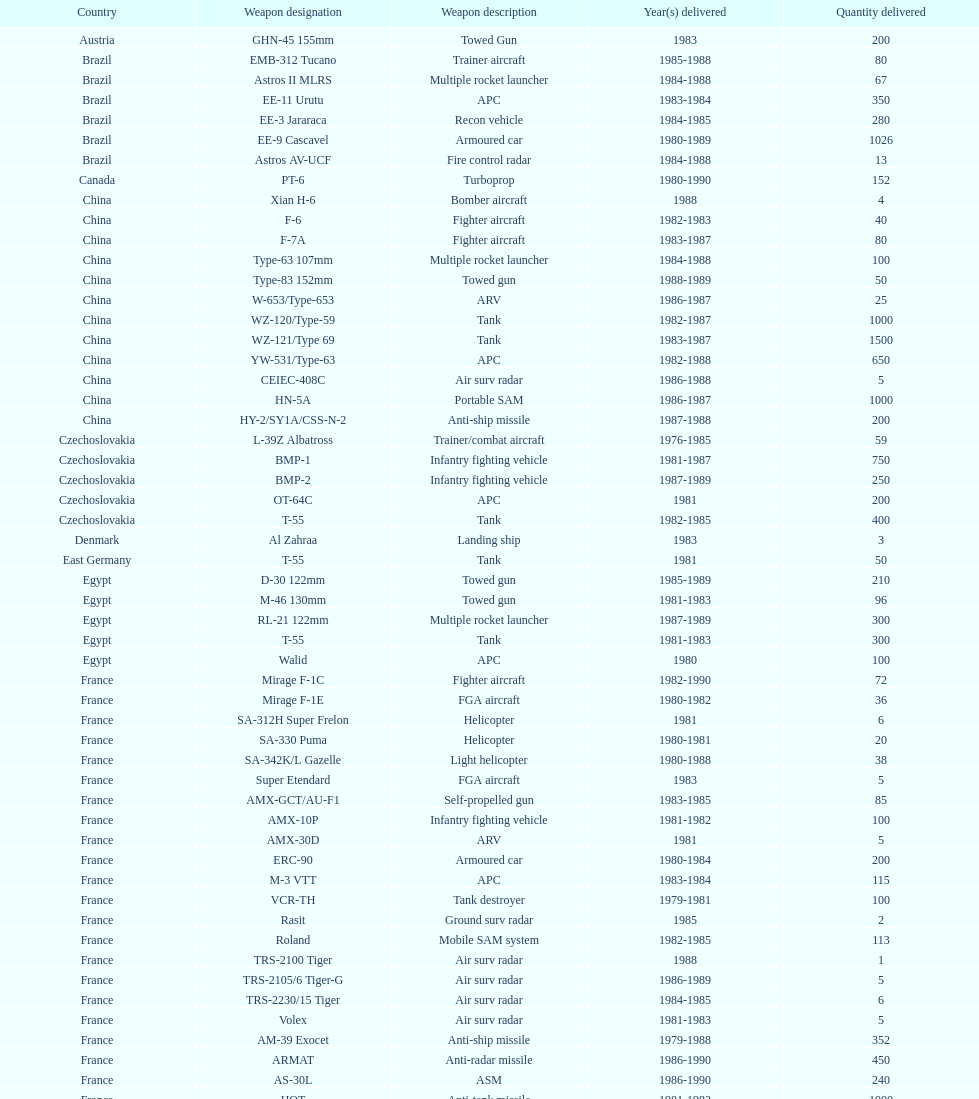Based on this list, how many nations supplied arms to iraq? 21. Can you give me this table as a dict? {'header': ['Country', 'Weapon designation', 'Weapon description', 'Year(s) delivered', 'Quantity delivered'], 'rows': [['Austria', 'GHN-45 155mm', 'Towed Gun', '1983', '200'], ['Brazil', 'EMB-312 Tucano', 'Trainer aircraft', '1985-1988', '80'], ['Brazil', 'Astros II MLRS', 'Multiple rocket launcher', '1984-1988', '67'], ['Brazil', 'EE-11 Urutu', 'APC', '1983-1984', '350'], ['Brazil', 'EE-3 Jararaca', 'Recon vehicle', '1984-1985', '280'], ['Brazil', 'EE-9 Cascavel', 'Armoured car', '1980-1989', '1026'], ['Brazil', 'Astros AV-UCF', 'Fire control radar', '1984-1988', '13'], ['Canada', 'PT-6', 'Turboprop', '1980-1990', '152'], ['China', 'Xian H-6', 'Bomber aircraft', '1988', '4'], ['China', 'F-6', 'Fighter aircraft', '1982-1983', '40'], ['China', 'F-7A', 'Fighter aircraft', '1983-1987', '80'], ['China', 'Type-63 107mm', 'Multiple rocket launcher', '1984-1988', '100'], ['China', 'Type-83 152mm', 'Towed gun', '1988-1989', '50'], ['China', 'W-653/Type-653', 'ARV', '1986-1987', '25'], ['China', 'WZ-120/Type-59', 'Tank', '1982-1987', '1000'], ['China', 'WZ-121/Type 69', 'Tank', '1983-1987', '1500'], ['China', 'YW-531/Type-63', 'APC', '1982-1988', '650'], ['China', 'CEIEC-408C', 'Air surv radar', '1986-1988', '5'], ['China', 'HN-5A', 'Portable SAM', '1986-1987', '1000'], ['China', 'HY-2/SY1A/CSS-N-2', 'Anti-ship missile', '1987-1988', '200'], ['Czechoslovakia', 'L-39Z Albatross', 'Trainer/combat aircraft', '1976-1985', '59'], ['Czechoslovakia', 'BMP-1', 'Infantry fighting vehicle', '1981-1987', '750'], ['Czechoslovakia', 'BMP-2', 'Infantry fighting vehicle', '1987-1989', '250'], ['Czechoslovakia', 'OT-64C', 'APC', '1981', '200'], ['Czechoslovakia', 'T-55', 'Tank', '1982-1985', '400'], ['Denmark', 'Al Zahraa', 'Landing ship', '1983', '3'], ['East Germany', 'T-55', 'Tank', '1981', '50'], ['Egypt', 'D-30 122mm', 'Towed gun', '1985-1989', '210'], ['Egypt', 'M-46 130mm', 'Towed gun', '1981-1983', '96'], ['Egypt', 'RL-21 122mm', 'Multiple rocket launcher', '1987-1989', '300'], ['Egypt', 'T-55', 'Tank', '1981-1983', '300'], ['Egypt', 'Walid', 'APC', '1980', '100'], ['France', 'Mirage F-1C', 'Fighter aircraft', '1982-1990', '72'], ['France', 'Mirage F-1E', 'FGA aircraft', '1980-1982', '36'], ['France', 'SA-312H Super Frelon', 'Helicopter', '1981', '6'], ['France', 'SA-330 Puma', 'Helicopter', '1980-1981', '20'], ['France', 'SA-342K/L Gazelle', 'Light helicopter', '1980-1988', '38'], ['France', 'Super Etendard', 'FGA aircraft', '1983', '5'], ['France', 'AMX-GCT/AU-F1', 'Self-propelled gun', '1983-1985', '85'], ['France', 'AMX-10P', 'Infantry fighting vehicle', '1981-1982', '100'], ['France', 'AMX-30D', 'ARV', '1981', '5'], ['France', 'ERC-90', 'Armoured car', '1980-1984', '200'], ['France', 'M-3 VTT', 'APC', '1983-1984', '115'], ['France', 'VCR-TH', 'Tank destroyer', '1979-1981', '100'], ['France', 'Rasit', 'Ground surv radar', '1985', '2'], ['France', 'Roland', 'Mobile SAM system', '1982-1985', '113'], ['France', 'TRS-2100 Tiger', 'Air surv radar', '1988', '1'], ['France', 'TRS-2105/6 Tiger-G', 'Air surv radar', '1986-1989', '5'], ['France', 'TRS-2230/15 Tiger', 'Air surv radar', '1984-1985', '6'], ['France', 'Volex', 'Air surv radar', '1981-1983', '5'], ['France', 'AM-39 Exocet', 'Anti-ship missile', '1979-1988', '352'], ['France', 'ARMAT', 'Anti-radar missile', '1986-1990', '450'], ['France', 'AS-30L', 'ASM', '1986-1990', '240'], ['France', 'HOT', 'Anti-tank missile', '1981-1982', '1000'], ['France', 'R-550 Magic-1', 'SRAAM', '1981-1985', '534'], ['France', 'Roland-2', 'SAM', '1981-1990', '2260'], ['France', 'Super 530F', 'BVRAAM', '1981-1985', '300'], ['West Germany', 'BK-117', 'Helicopter', '1984-1989', '22'], ['West Germany', 'Bo-105C', 'Light Helicopter', '1979-1982', '20'], ['West Germany', 'Bo-105L', 'Light Helicopter', '1988', '6'], ['Hungary', 'PSZH-D-994', 'APC', '1981', '300'], ['Italy', 'A-109 Hirundo', 'Light Helicopter', '1982', '2'], ['Italy', 'S-61', 'Helicopter', '1982', '6'], ['Italy', 'Stromboli class', 'Support ship', '1981', '1'], ['Jordan', 'S-76 Spirit', 'Helicopter', '1985', '2'], ['Poland', 'Mi-2/Hoplite', 'Helicopter', '1984-1985', '15'], ['Poland', 'MT-LB', 'APC', '1983-1990', '750'], ['Poland', 'T-55', 'Tank', '1981-1982', '400'], ['Poland', 'T-72M1', 'Tank', '1982-1990', '500'], ['Romania', 'T-55', 'Tank', '1982-1984', '150'], ['Yugoslavia', 'M-87 Orkan 262mm', 'Multiple rocket launcher', '1988', '2'], ['South Africa', 'G-5 155mm', 'Towed gun', '1985-1988', '200'], ['Switzerland', 'PC-7 Turbo trainer', 'Trainer aircraft', '1980-1983', '52'], ['Switzerland', 'PC-9', 'Trainer aircraft', '1987-1990', '20'], ['Switzerland', 'Roland', 'APC/IFV', '1981', '100'], ['United Kingdom', 'Chieftain/ARV', 'ARV', '1982', '29'], ['United Kingdom', 'Cymbeline', 'Arty locating radar', '1986-1988', '10'], ['United States', 'MD-500MD Defender', 'Light Helicopter', '1983', '30'], ['United States', 'Hughes-300/TH-55', 'Light Helicopter', '1983', '30'], ['United States', 'MD-530F', 'Light Helicopter', '1986', '26'], ['United States', 'Bell 214ST', 'Helicopter', '1988', '31'], ['Soviet Union', 'Il-76M/Candid-B', 'Strategic airlifter', '1978-1984', '33'], ['Soviet Union', 'Mi-24D/Mi-25/Hind-D', 'Attack helicopter', '1978-1984', '12'], ['Soviet Union', 'Mi-8/Mi-17/Hip-H', 'Transport helicopter', '1986-1987', '37'], ['Soviet Union', 'Mi-8TV/Hip-F', 'Transport helicopter', '1984', '30'], ['Soviet Union', 'Mig-21bis/Fishbed-N', 'Fighter aircraft', '1983-1984', '61'], ['Soviet Union', 'Mig-23BN/Flogger-H', 'FGA aircraft', '1984-1985', '50'], ['Soviet Union', 'Mig-25P/Foxbat-A', 'Interceptor aircraft', '1980-1985', '55'], ['Soviet Union', 'Mig-25RB/Foxbat-B', 'Recon aircraft', '1982', '8'], ['Soviet Union', 'Mig-29/Fulcrum-A', 'Fighter aircraft', '1986-1989', '41'], ['Soviet Union', 'Su-22/Fitter-H/J/K', 'FGA aircraft', '1986-1987', '61'], ['Soviet Union', 'Su-25/Frogfoot-A', 'Ground attack aircraft', '1986-1987', '84'], ['Soviet Union', '2A36 152mm', 'Towed gun', '1986-1988', '180'], ['Soviet Union', '2S1 122mm', 'Self-Propelled Howitzer', '1980-1989', '150'], ['Soviet Union', '2S3 152mm', 'Self-propelled gun', '1980-1989', '150'], ['Soviet Union', '2S4 240mm', 'Self-propelled mortar', '1983', '10'], ['Soviet Union', '9P117/SS-1 Scud TEL', 'SSM launcher', '1983-1984', '10'], ['Soviet Union', 'BM-21 Grad 122mm', 'Multiple rocket launcher', '1983-1988', '560'], ['Soviet Union', 'D-30 122mm', 'Towed gun', '1982-1988', '576'], ['Soviet Union', 'M-240 240mm', 'Mortar', '1981', '25'], ['Soviet Union', 'M-46 130mm', 'Towed Gun', '1982-1987', '576'], ['Soviet Union', '9K35 Strela-10/SA-13', 'AAV(M)', '1985', '30'], ['Soviet Union', 'BMD-1', 'IFV', '1981', '10'], ['Soviet Union', 'PT-76', 'Light tank', '1984', '200'], ['Soviet Union', 'SA-9/9P31', 'AAV(M)', '1982-1985', '160'], ['Soviet Union', 'Long Track', 'Air surv radar', '1980-1984', '10'], ['Soviet Union', 'SA-8b/9K33M Osa AK', 'Mobile SAM system', '1982-1985', '50'], ['Soviet Union', 'Thin Skin', 'Air surv radar', '1980-1984', '5'], ['Soviet Union', '9M111/AT-4 Spigot', 'Anti-tank missile', '1986-1989', '3000'], ['Soviet Union', '9M37/SA-13 Gopher', 'SAM', '1985-1986', '960'], ['Soviet Union', 'KSR-5/AS-6 Kingfish', 'Anti-ship missile', '1984', '36'], ['Soviet Union', 'Kh-28/AS-9 Kyle', 'Anti-radar missile', '1983-1988', '250'], ['Soviet Union', 'R-13S/AA2S Atoll', 'SRAAM', '1984-1987', '1080'], ['Soviet Union', 'R-17/SS-1c Scud-B', 'SSM', '1982-1988', '840'], ['Soviet Union', 'R-27/AA-10 Alamo', 'BVRAAM', '1986-1989', '246'], ['Soviet Union', 'R-40R/AA-6 Acrid', 'BVRAAM', '1980-1985', '660'], ['Soviet Union', 'R-60/AA-8 Aphid', 'SRAAM', '1986-1989', '582'], ['Soviet Union', 'SA-8b Gecko/9M33M', 'SAM', '1982-1985', '1290'], ['Soviet Union', 'SA-9 Gaskin/9M31', 'SAM', '1982-1985', '1920'], ['Soviet Union', 'Strela-3/SA-14 Gremlin', 'Portable SAM', '1987-1988', '500']]} 